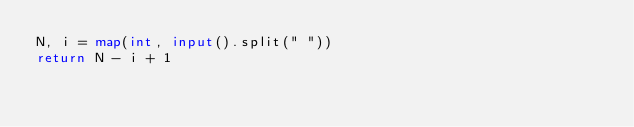Convert code to text. <code><loc_0><loc_0><loc_500><loc_500><_Python_>N, i = map(int, input().split(" "))
return N - i + 1</code> 